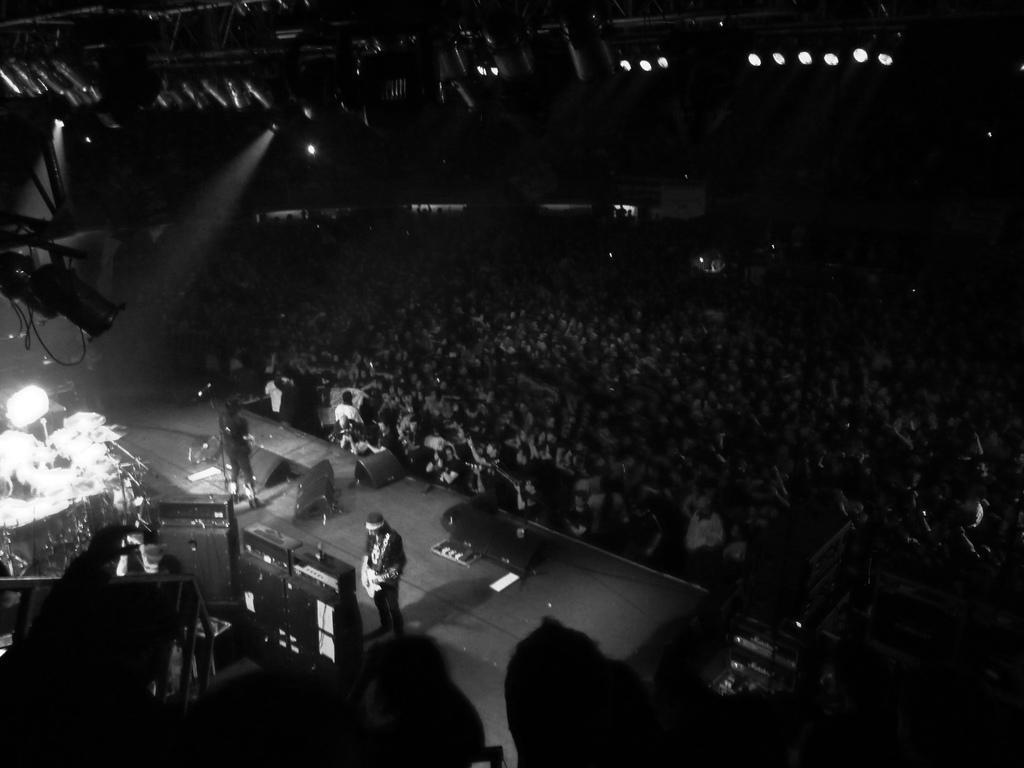Please provide a concise description of this image. In this picture we can see two persons standing on the stage, there are some group of people on the right side, this person is playing a guitar, we can see lights at the top of the picture, there are some musical instruments here. 